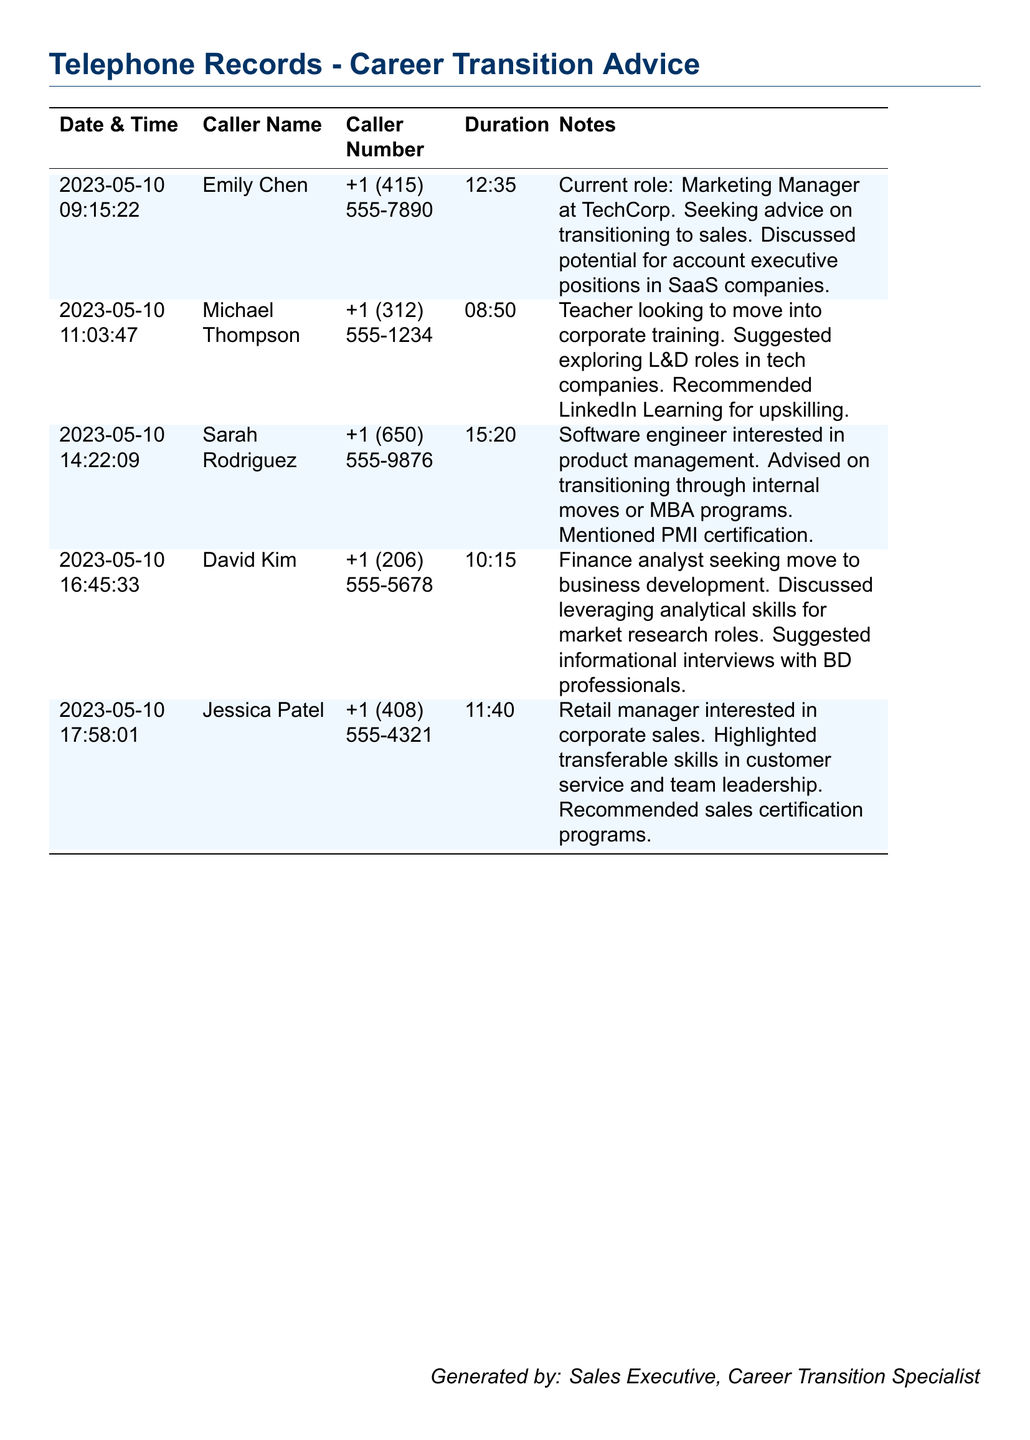What is the date and time of the first call? The first call's date and time is listed at the top of the records.
Answer: 2023-05-10 09:15:22 Who is the caller seeking advice on transitioning to sales? The caller's name is mentioned along with their inquiry about career transition to sales.
Answer: Emily Chen What is the duration of the call with Sarah Rodriguez? The duration indicates how long the call with this particular caller lasted.
Answer: 15:20 Which caller is interested in moving into corporate training? Based on the notes, this caller's career transition goal is specified clearly.
Answer: Michael Thompson How many callers contacted regarding positions in sales? The total count is derived from the notes mentioning interest in sales roles.
Answer: 2 